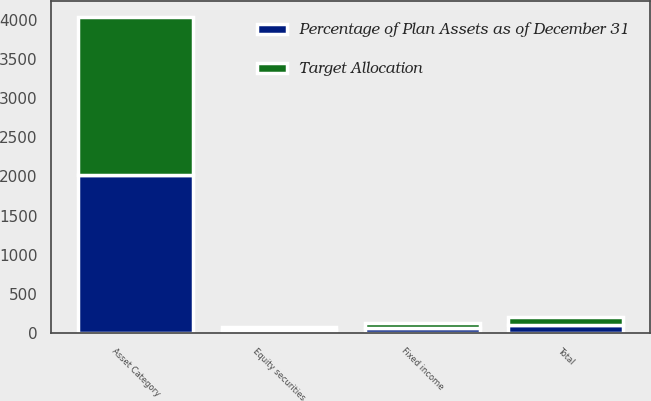Convert chart. <chart><loc_0><loc_0><loc_500><loc_500><stacked_bar_chart><ecel><fcel>Asset Category<fcel>Equity securities<fcel>Fixed income<fcel>Total<nl><fcel>Target Allocation<fcel>2018<fcel>38<fcel>62<fcel>100<nl><fcel>Percentage of Plan Assets as of December 31<fcel>2017<fcel>35<fcel>65<fcel>100<nl></chart> 